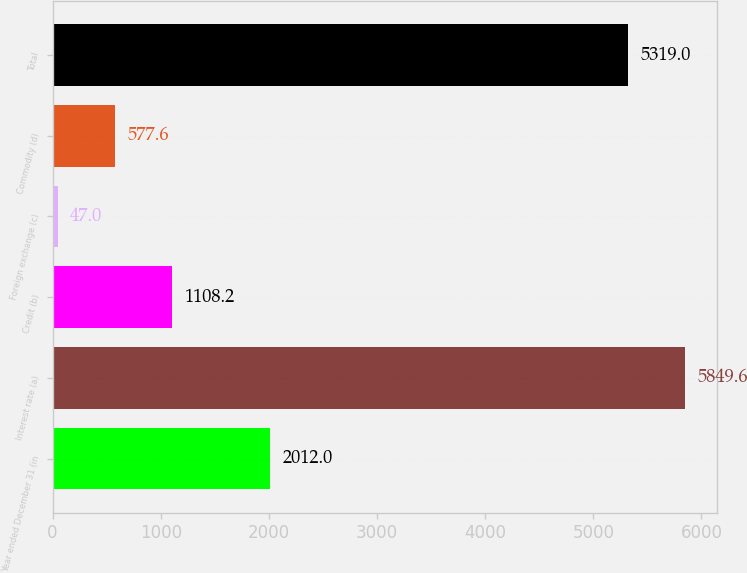<chart> <loc_0><loc_0><loc_500><loc_500><bar_chart><fcel>Year ended December 31 (in<fcel>Interest rate (a)<fcel>Credit (b)<fcel>Foreign exchange (c)<fcel>Commodity (d)<fcel>Total<nl><fcel>2012<fcel>5849.6<fcel>1108.2<fcel>47<fcel>577.6<fcel>5319<nl></chart> 